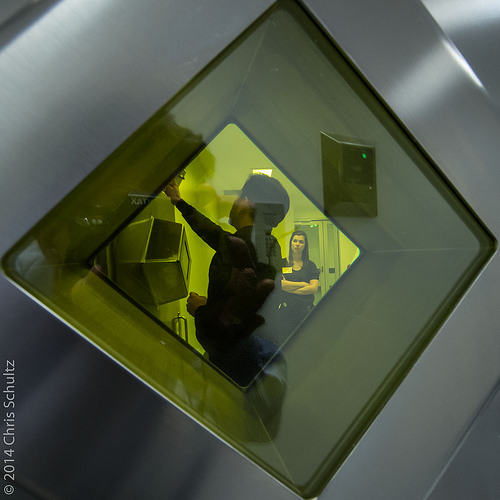<image>
Is the man in front of the woman? Yes. The man is positioned in front of the woman, appearing closer to the camera viewpoint. 